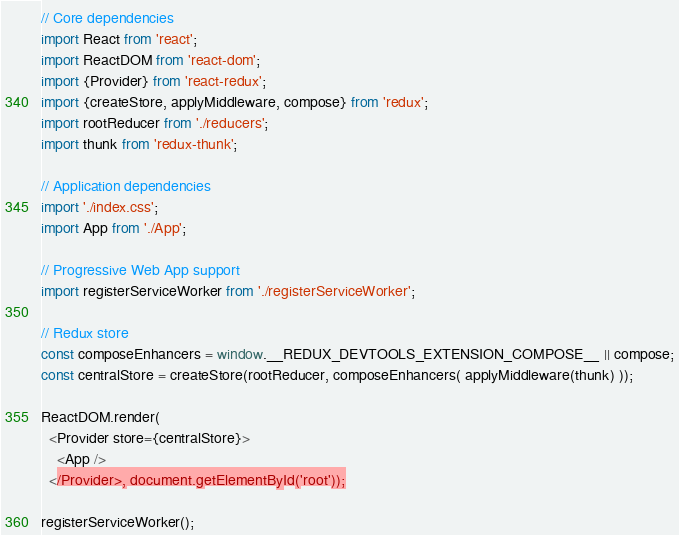Convert code to text. <code><loc_0><loc_0><loc_500><loc_500><_JavaScript_>// Core dependencies
import React from 'react';
import ReactDOM from 'react-dom';
import {Provider} from 'react-redux';
import {createStore, applyMiddleware, compose} from 'redux';
import rootReducer from './reducers';
import thunk from 'redux-thunk';

// Application dependencies
import './index.css';
import App from './App';

// Progressive Web App support
import registerServiceWorker from './registerServiceWorker';

// Redux store
const composeEnhancers = window.__REDUX_DEVTOOLS_EXTENSION_COMPOSE__ || compose;
const centralStore = createStore(rootReducer, composeEnhancers( applyMiddleware(thunk) ));

ReactDOM.render(
  <Provider store={centralStore}>
    <App />
  </Provider>, document.getElementById('root'));

registerServiceWorker();
</code> 